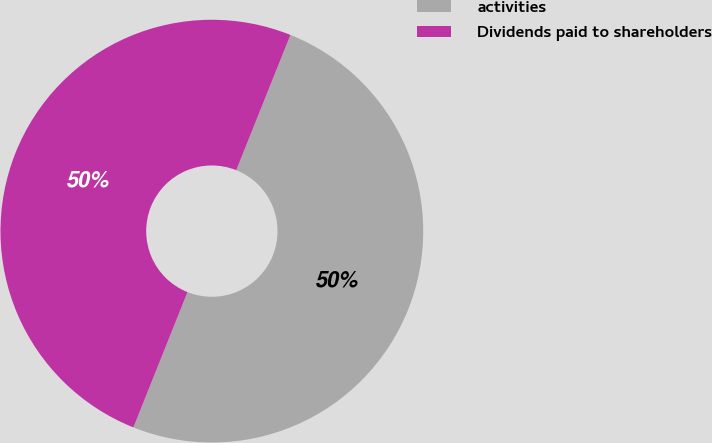<chart> <loc_0><loc_0><loc_500><loc_500><pie_chart><fcel>activities<fcel>Dividends paid to shareholders<nl><fcel>49.99%<fcel>50.01%<nl></chart> 